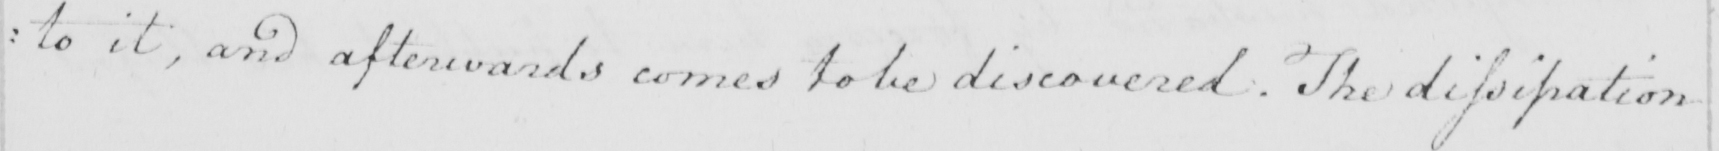Transcribe the text shown in this historical manuscript line. : to it , and afterwards comes to be discovered . The dissipation 